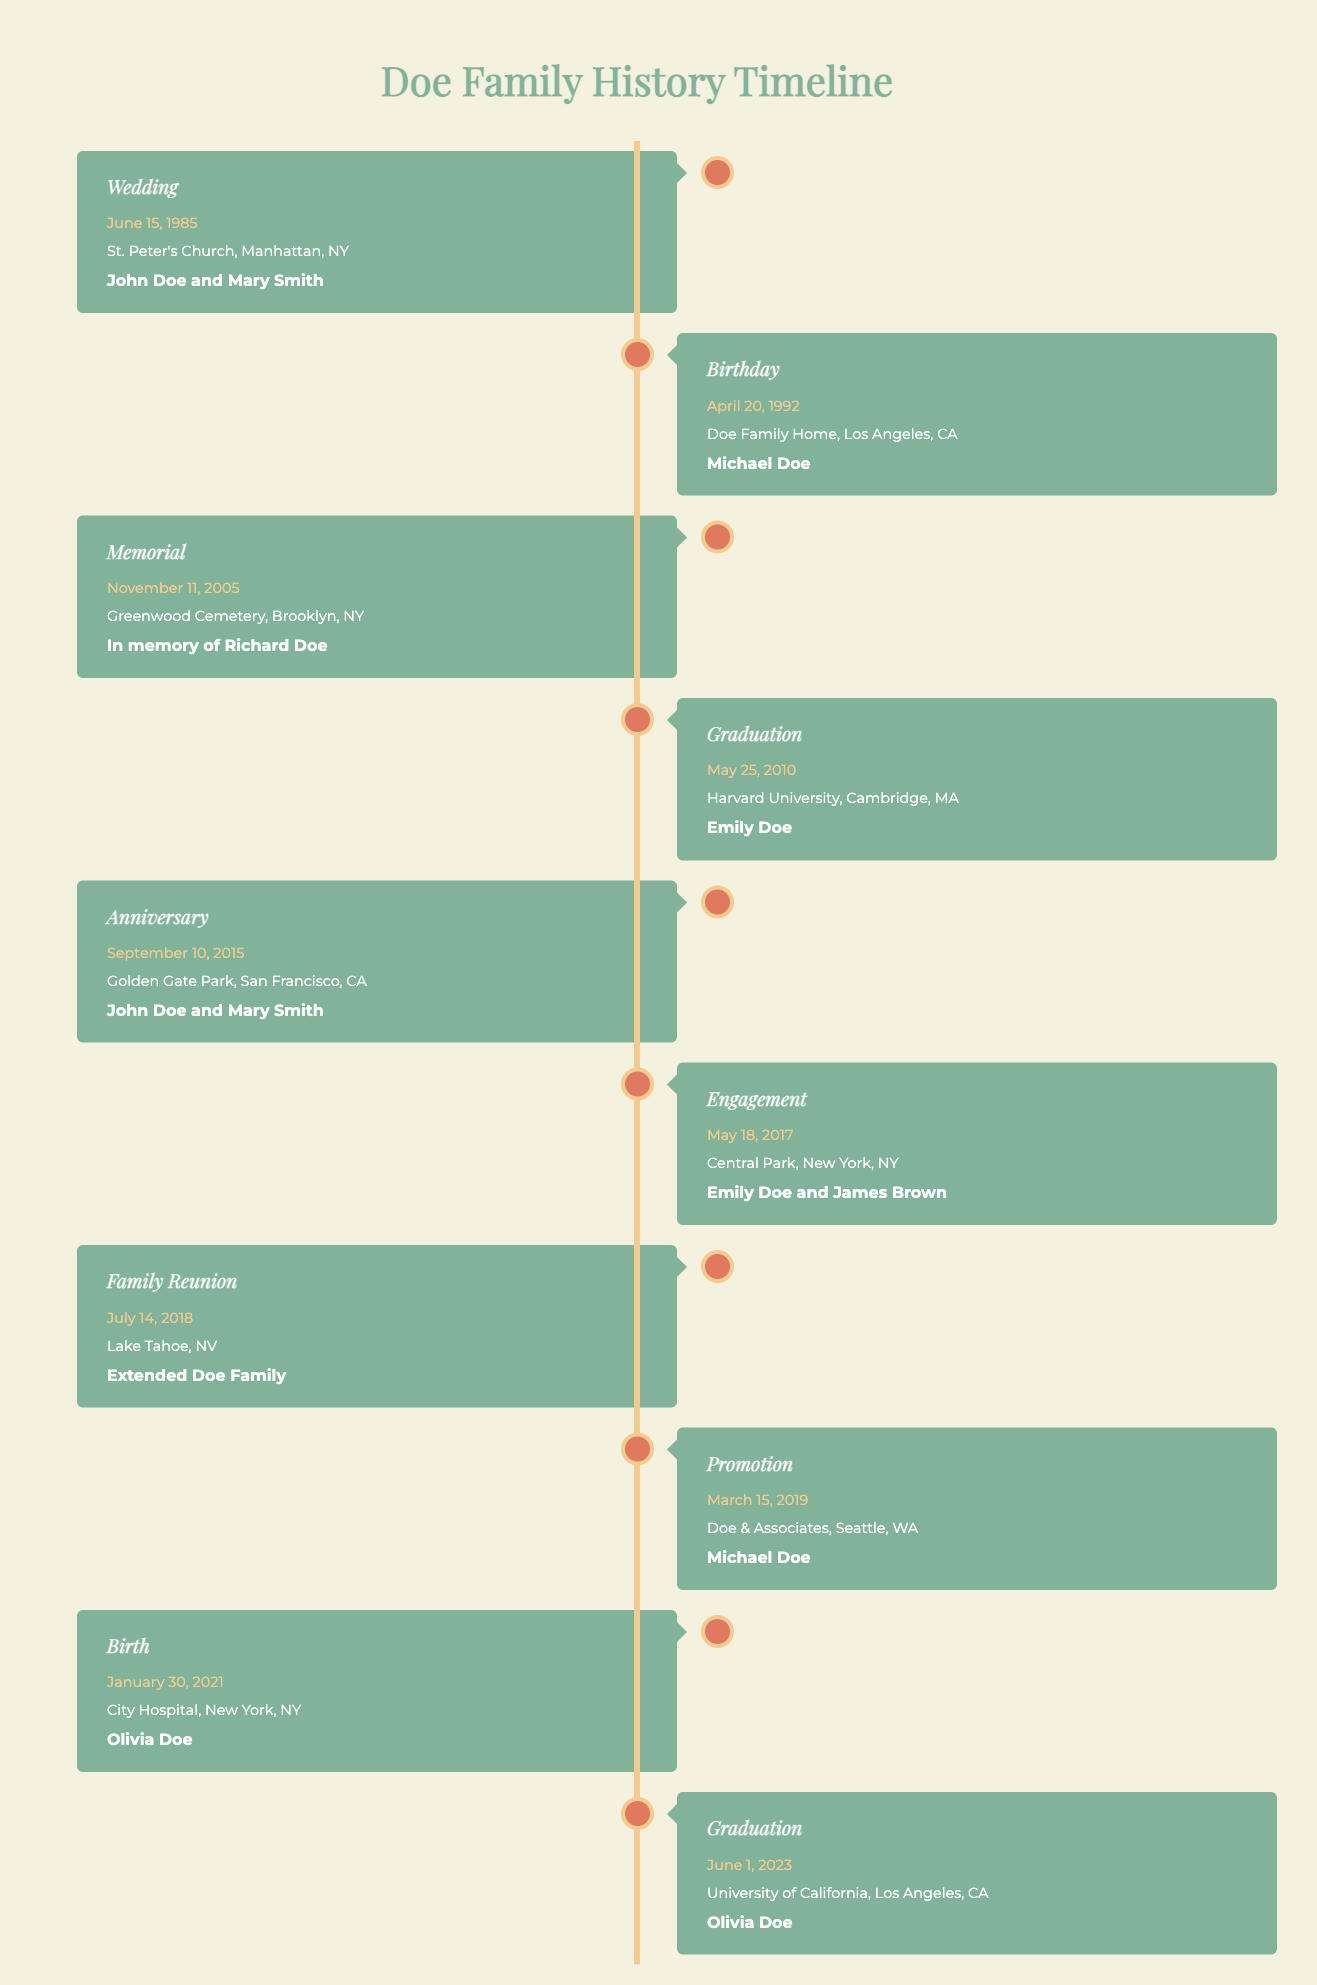What was the location of John Doe and Mary Smith's wedding? The table lists their wedding event with the event type "Wedding." The corresponding location is "St. Peter's Church, Manhattan, NY."
Answer: St. Peter's Church, Manhattan, NY Who graduated from Harvard University? The table indicates that the event is a "Graduation" and shows the family member associated with this event is "Emily Doe."
Answer: Emily Doe How many family events took place in New York? By counting the entries in the table, the locations categorized under New York include "St. Peter's Church, Manhattan, NY," "City Hospital, New York, NY," "Central Park, New York, NY," and "Greenwood Cemetery, Brooklyn, NY." Therefore, there are four events.
Answer: 4 Which family member's birthday took place in the 1990s? The table includes "Birthday" under the event type for "Michael Doe" on April 20, 1992. This means his birthday is from the 1990s.
Answer: Michael Doe Was there a family reunion in 2015? Looking through the events in the table, the family reunion is held in 2018. Therefore, it is false that there was a family reunion in 2015.
Answer: No When did Olivia Doe graduate? The entry for Olivia Doe shows the event type as "Graduation," which occurred on June 1, 2023, as noted in the table.
Answer: June 1, 2023 How many events were held in California? The events in California are "Birthday" at "Doe Family Home, Los Angeles, CA," "Graduation" at "University of California, Los Angeles, CA," "Family Reunion" at "Lake Tahoe, NV," and "Anniversary" at "Golden Gate Park, San Francisco, CA," totaling four events.
Answer: 4 Which event occurred first: the wedding or the birthday of Michael Doe? The wedding event for John Doe and Mary Smith on June 15, 1985, occurred before the birthday event for Michael Doe on April 20, 1992, thus the wedding happened first.
Answer: Wedding What type of event is most frequently represented in the table? The event types such as "Graduation," "Birthday," "Wedding," "Anniversary," "Family Reunion," "Memorial," "Engagement," "Promotion," and "Birth" are listed, with "Graduation" occurring twice for different individuals. However, no type is repeated more than once, making it a case of none being more frequent than others.
Answer: None If two family members are compared, who had the earlier significant event, Emily Doe's graduation or Michael Doe's promotion? Emily Doe graduated on May 25, 2010, while Michael Doe received a promotion on March 15, 2019. Since 2010 is earlier than 2019, Emily Doe’s event was earlier.
Answer: Emily Doe 